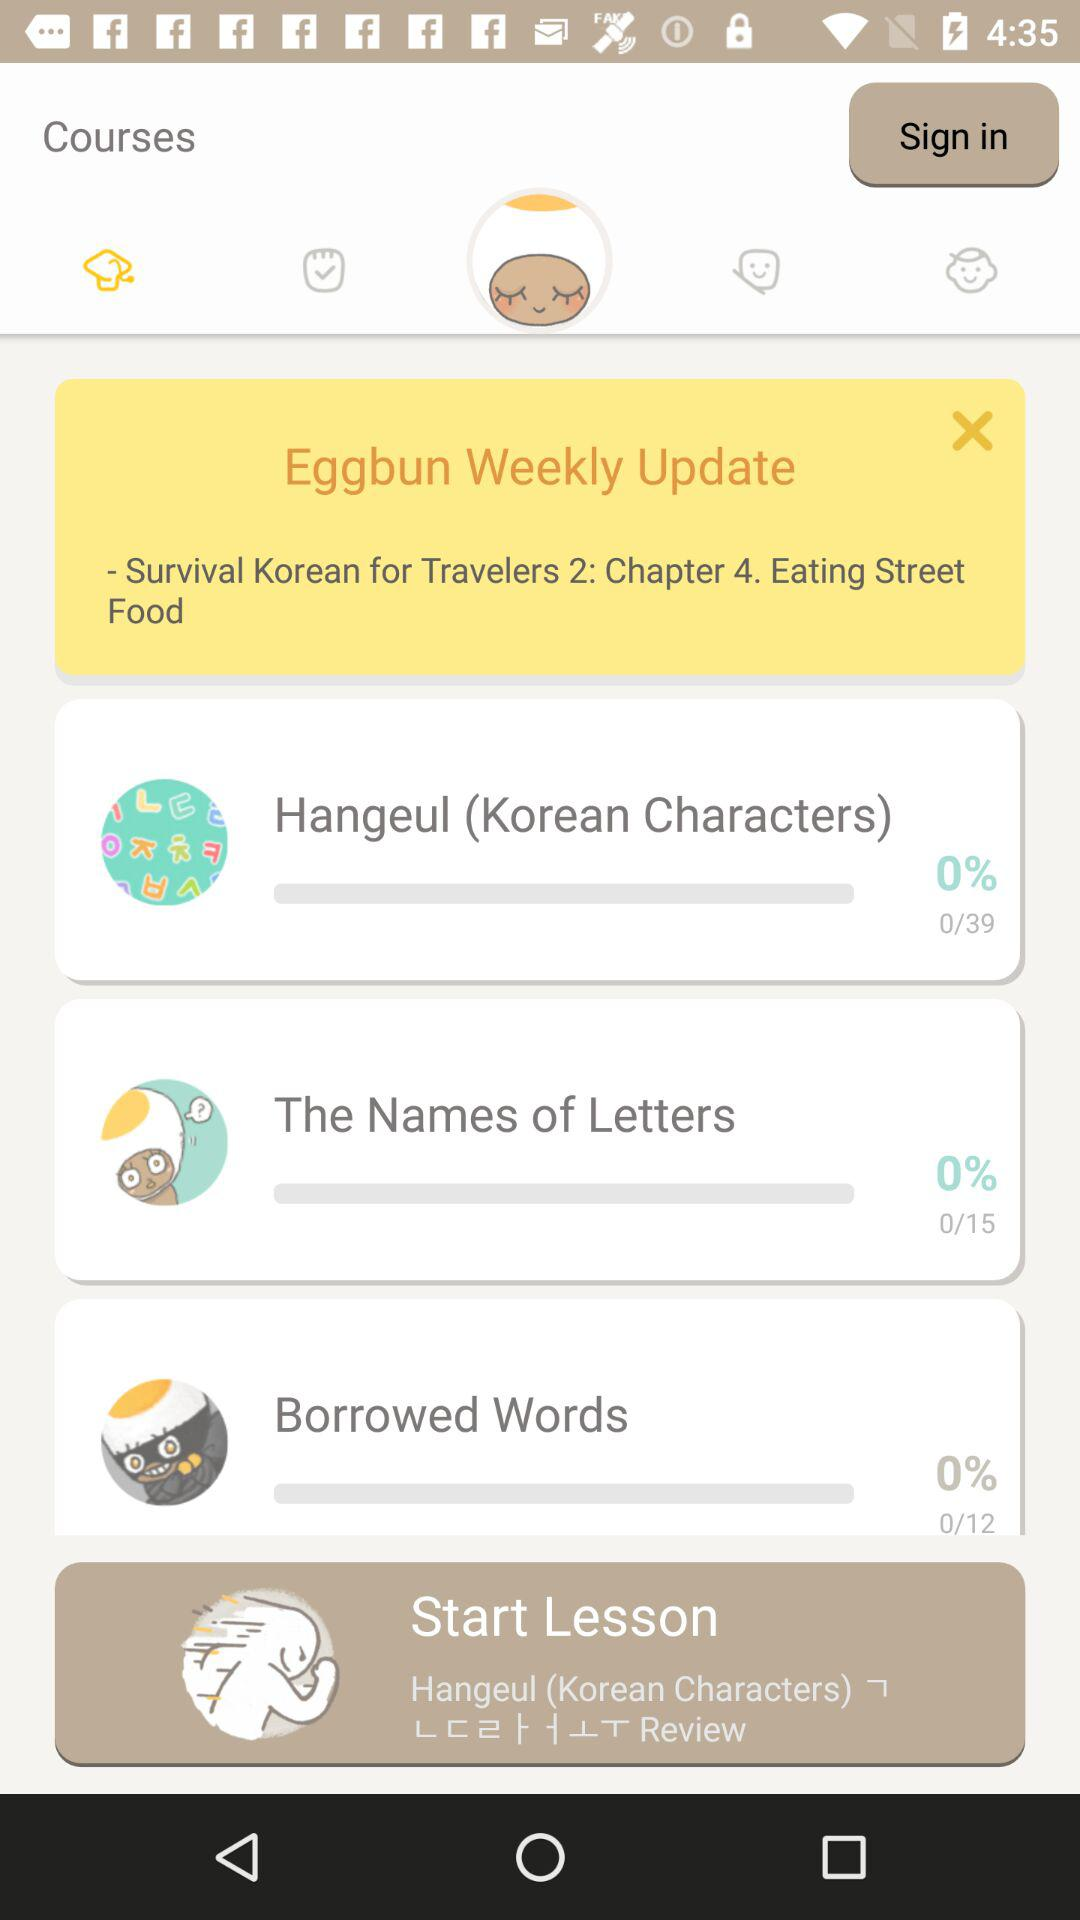What is the total count of "The Names of Letters"? The total count of "The Names of Letters" is 15. 